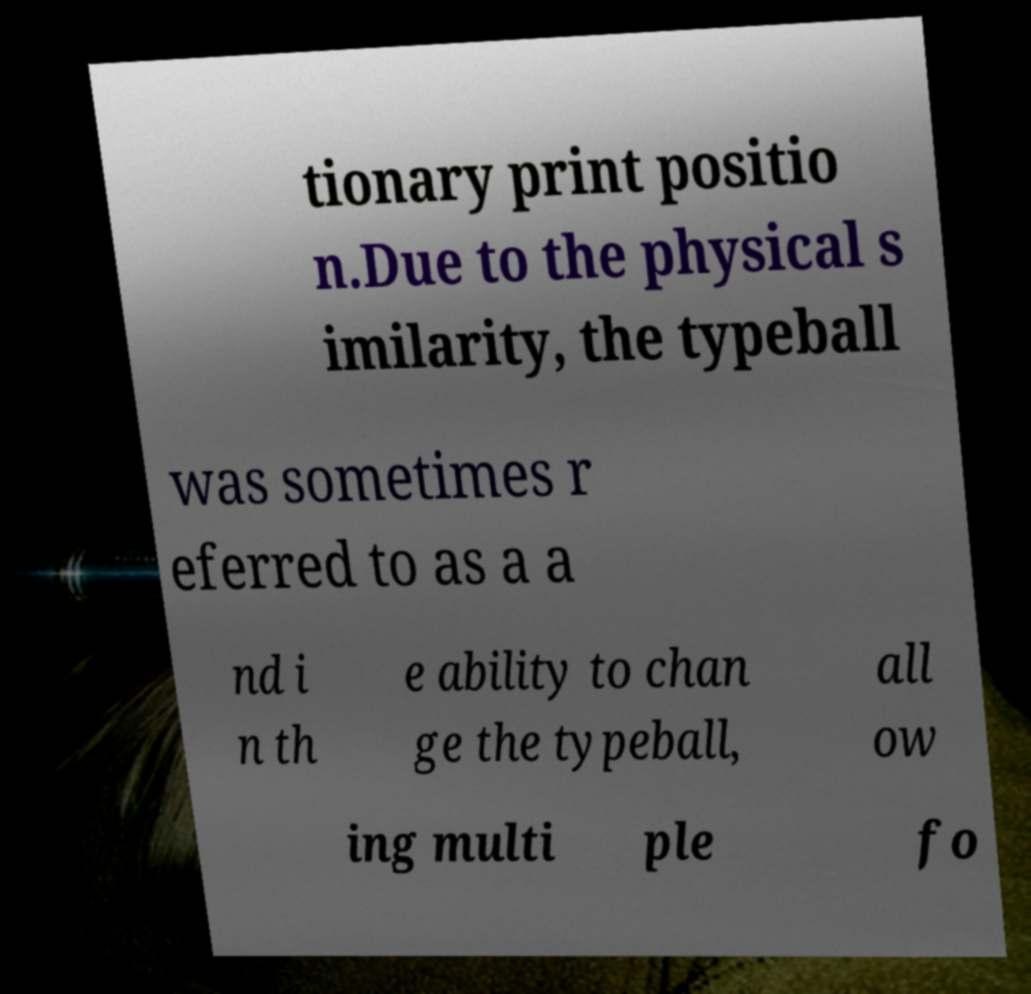For documentation purposes, I need the text within this image transcribed. Could you provide that? tionary print positio n.Due to the physical s imilarity, the typeball was sometimes r eferred to as a a nd i n th e ability to chan ge the typeball, all ow ing multi ple fo 